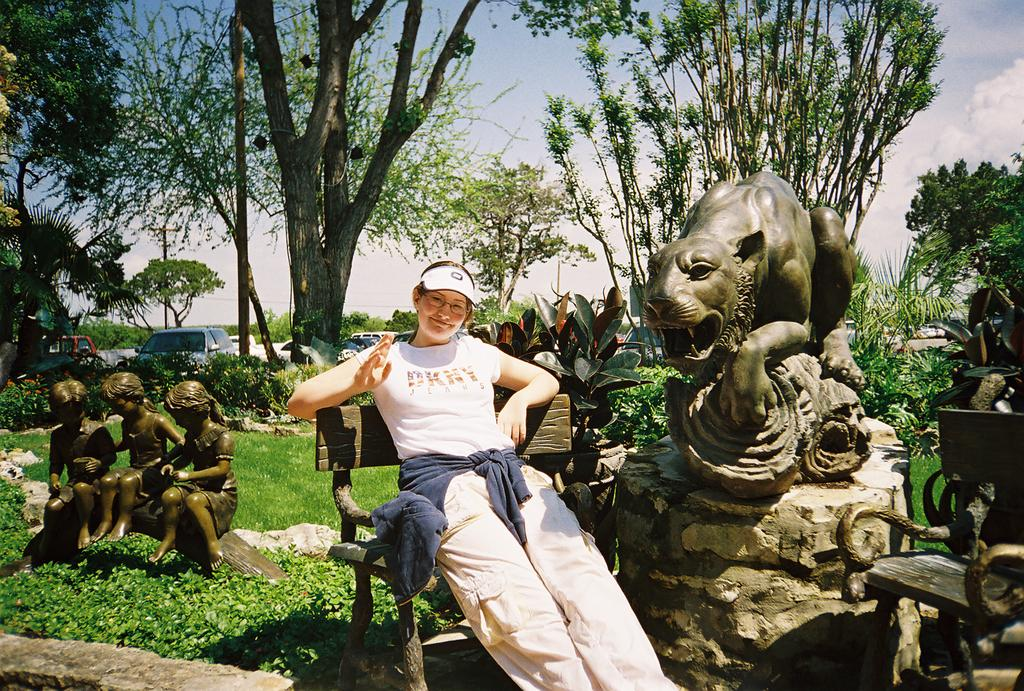What is the main subject of the image? There is a beautiful girl in the image. What is the girl doing in the image? The girl is sitting on a chair. What is the girl wearing in the image? The girl is wearing a white t-shirt. What can be seen on the left side of the image? There are statues on the left side of the image. What is visible in the background of the image? There are big trees in the background of the image. What type of test can be seen being conducted in the image? There is no test being conducted in the image; it features a girl sitting on a chair. What card game is being played in the image? There is no card game being played in the image; it features a girl sitting on a chair and big trees in the background. 